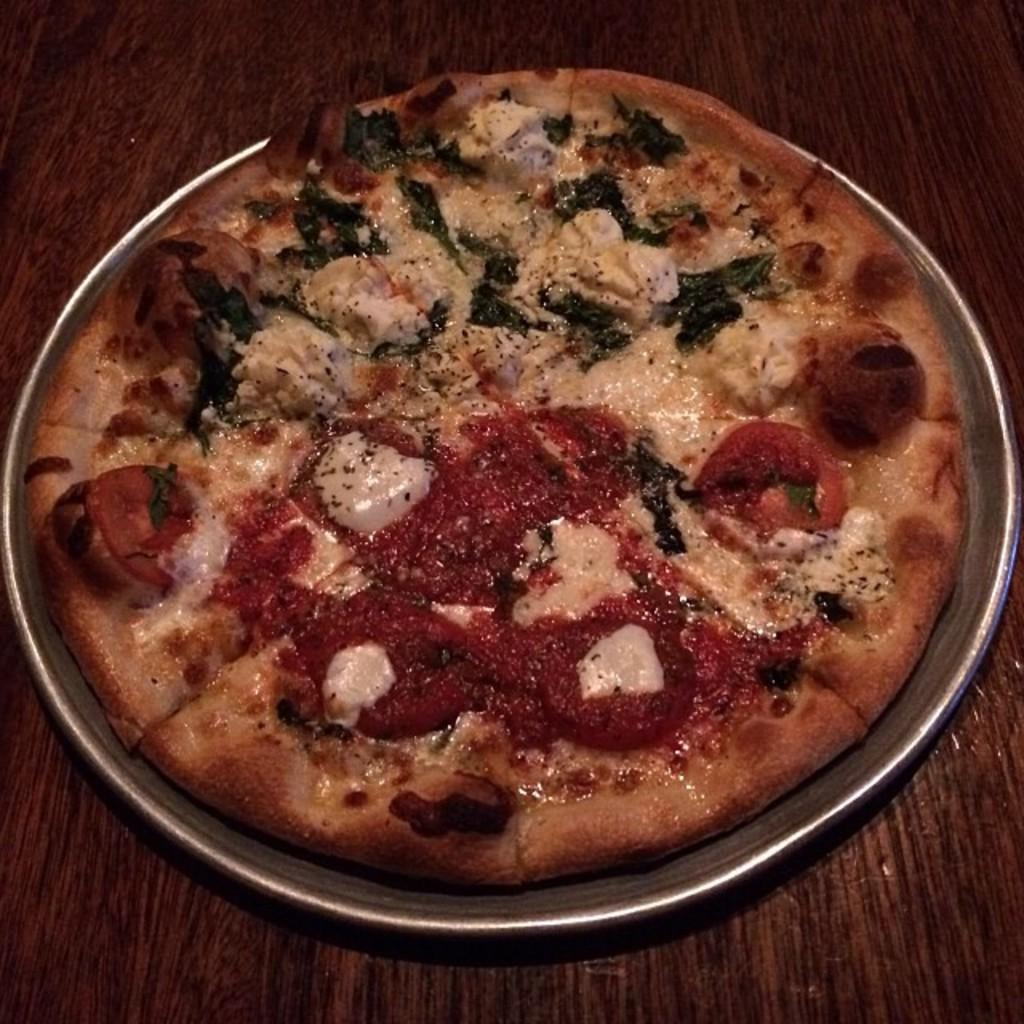Please provide a concise description of this image. In this image there is a pizza on a plate, on the table. 